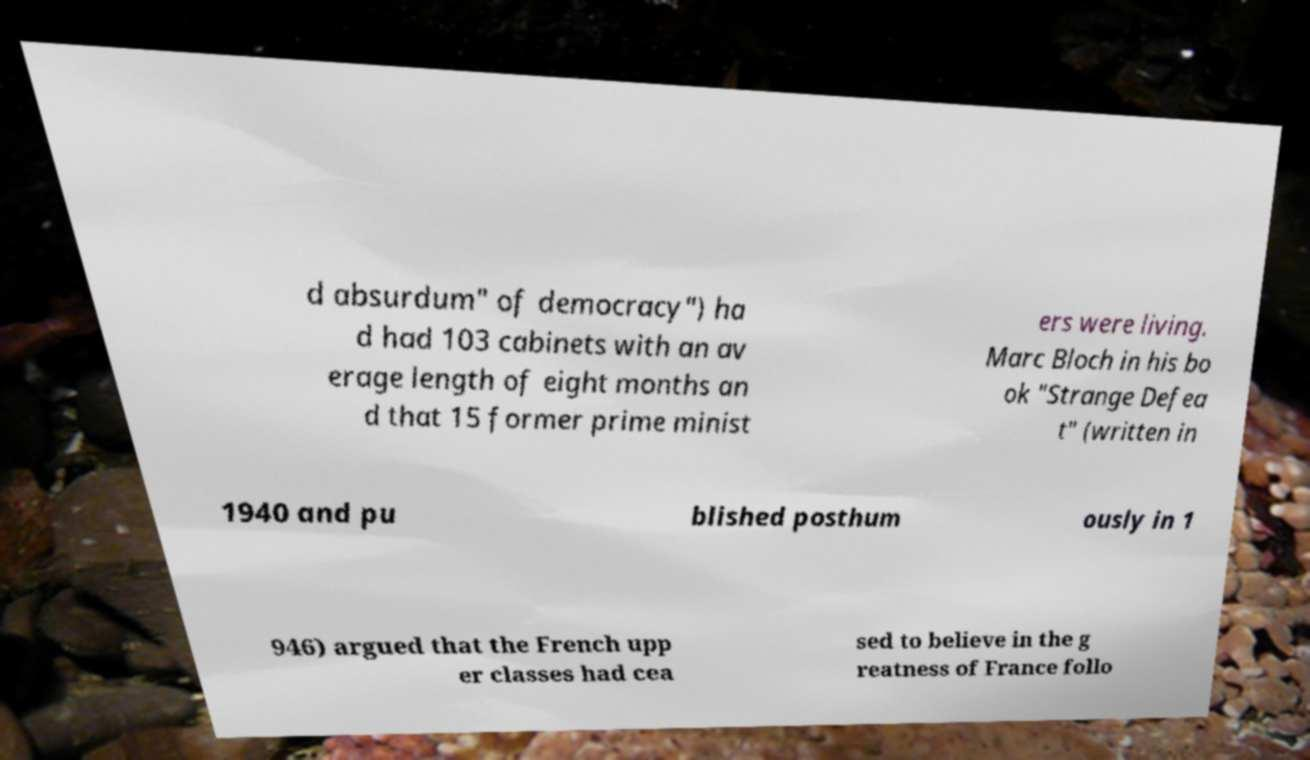There's text embedded in this image that I need extracted. Can you transcribe it verbatim? d absurdum" of democracy") ha d had 103 cabinets with an av erage length of eight months an d that 15 former prime minist ers were living. Marc Bloch in his bo ok "Strange Defea t" (written in 1940 and pu blished posthum ously in 1 946) argued that the French upp er classes had cea sed to believe in the g reatness of France follo 